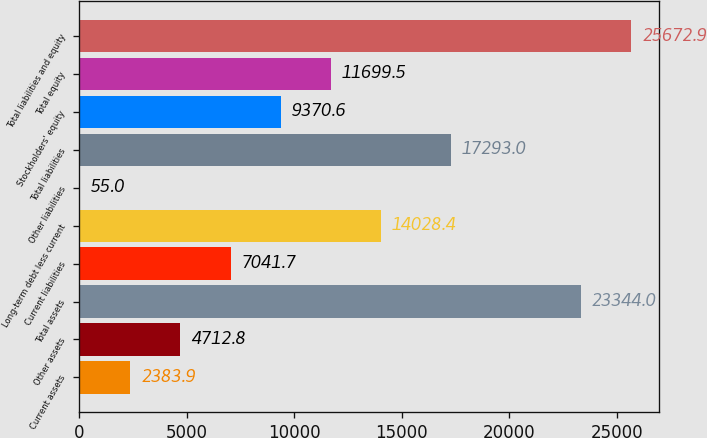<chart> <loc_0><loc_0><loc_500><loc_500><bar_chart><fcel>Current assets<fcel>Other assets<fcel>Total assets<fcel>Current liabilities<fcel>Long-term debt less current<fcel>Other liabilities<fcel>Total liabilities<fcel>Stockholders' equity<fcel>Total equity<fcel>Total liabilities and equity<nl><fcel>2383.9<fcel>4712.8<fcel>23344<fcel>7041.7<fcel>14028.4<fcel>55<fcel>17293<fcel>9370.6<fcel>11699.5<fcel>25672.9<nl></chart> 